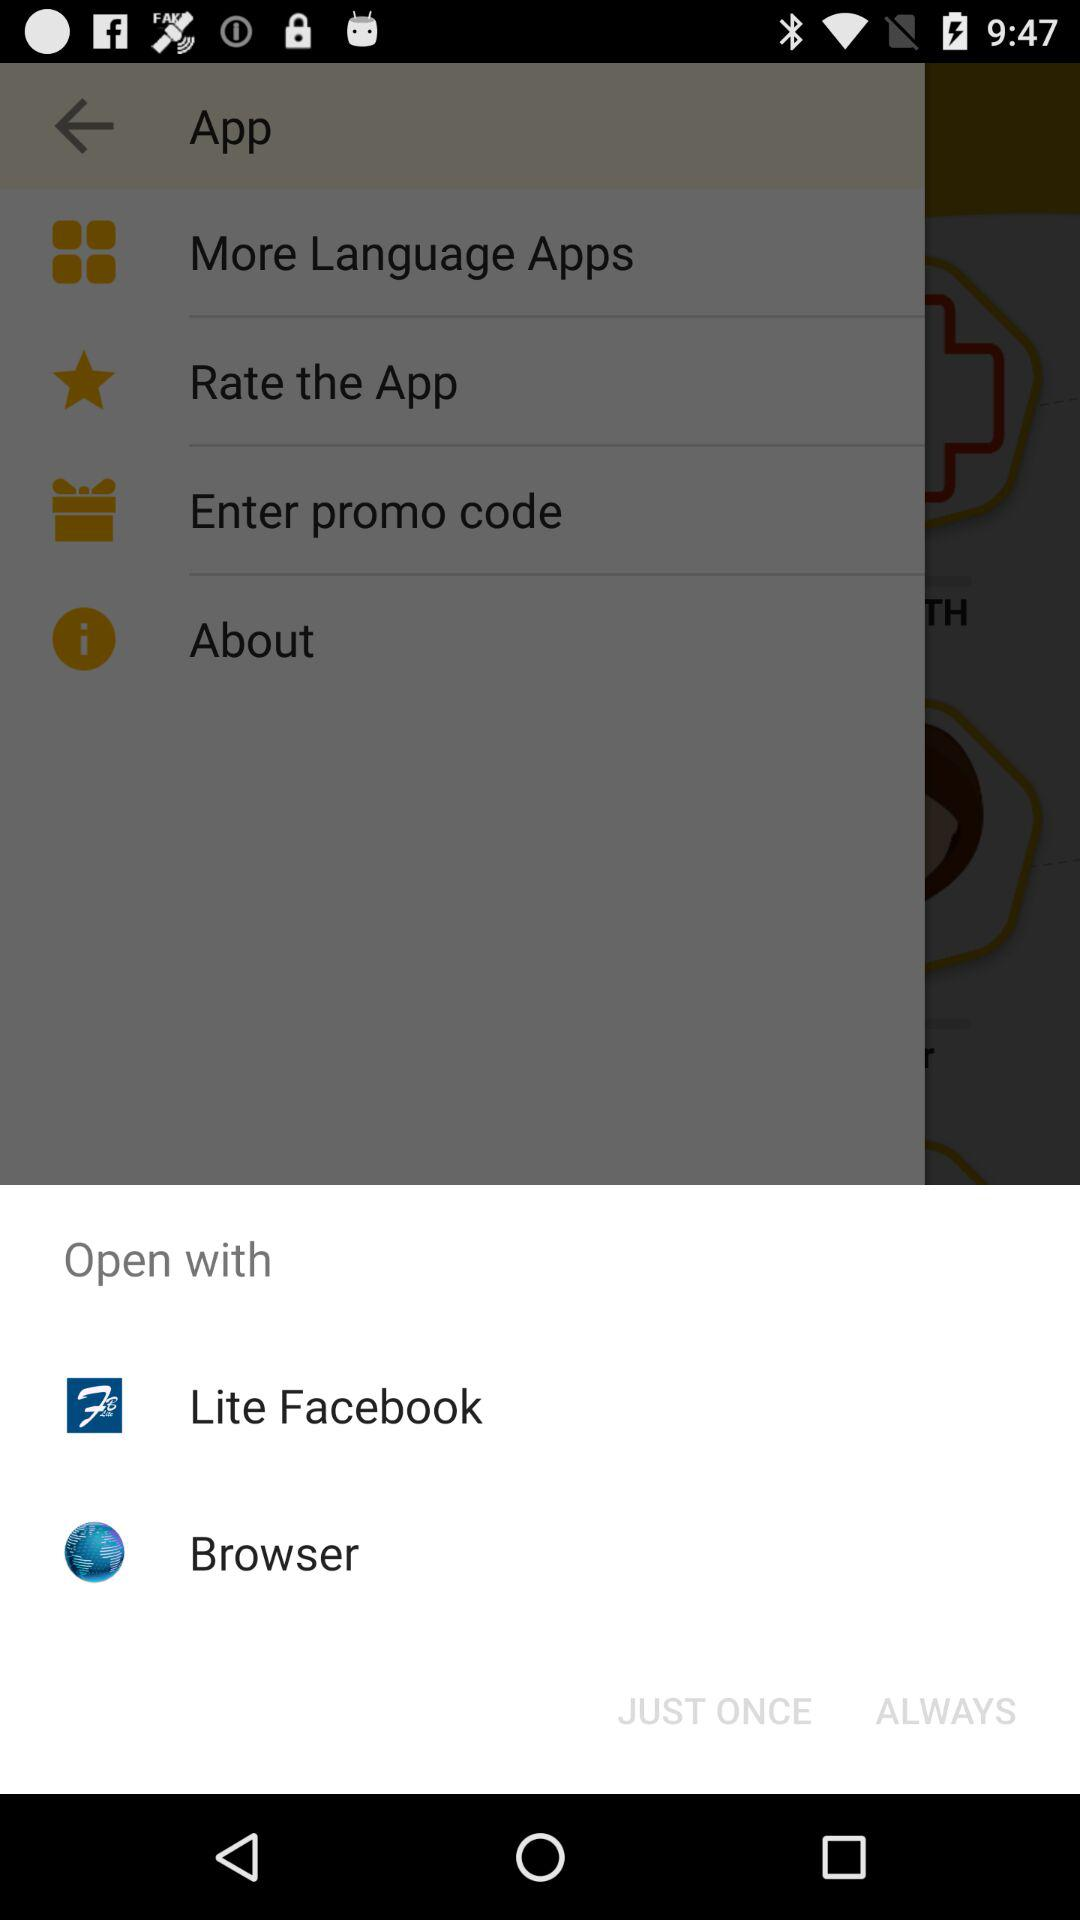What are the different applications we can use to open? The different applications are "Lite Facebook" and "Browser". 